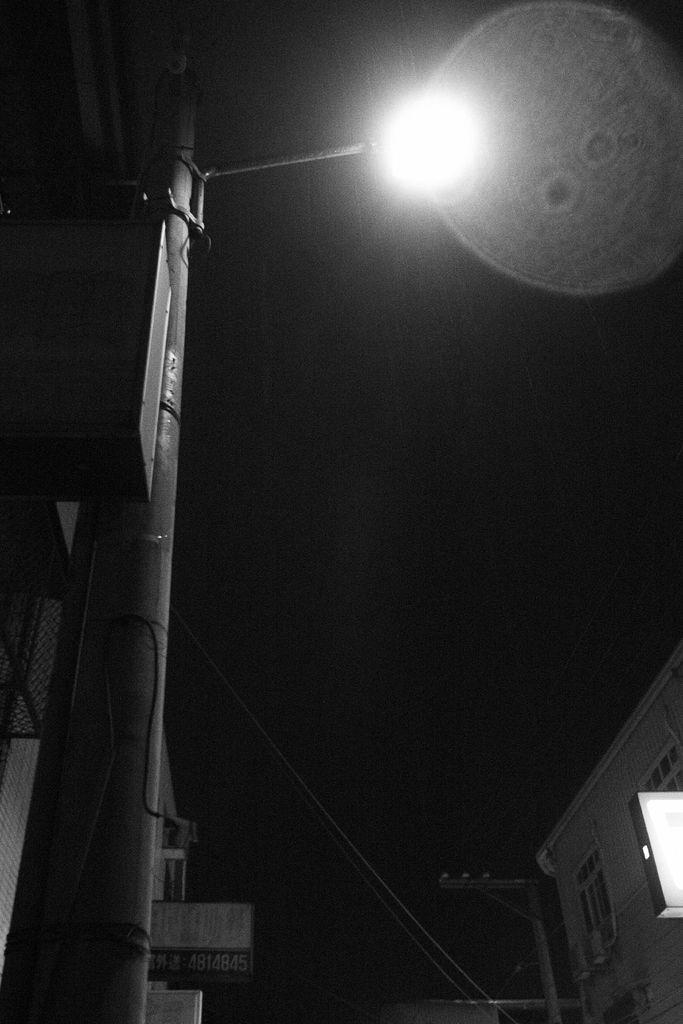What is the main object in the foreground of the image? There is a light pole in the image. What can be seen in the distance behind the light pole? There are buildings in the background of the image. What is the color of the sky in the image? The sky appears to be black in color. How many bears can be seen shopping in the image? There are no bears or shops present in the image. 